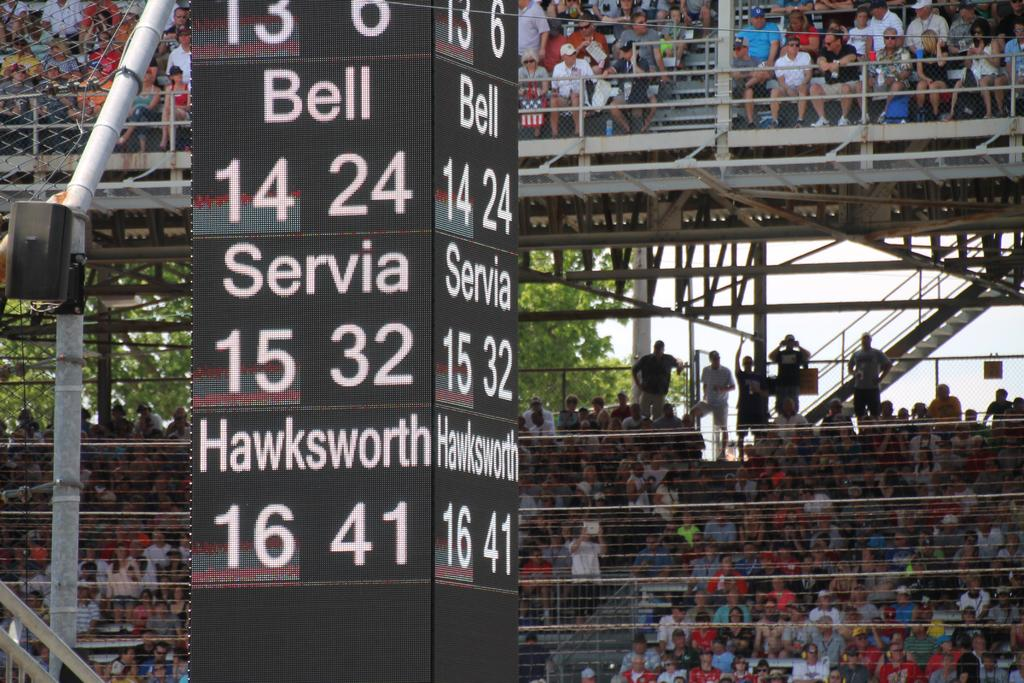<image>
Describe the image concisely. A stadium with multiple levels where people are watching a game between Bell Servia and Hawksworth. 